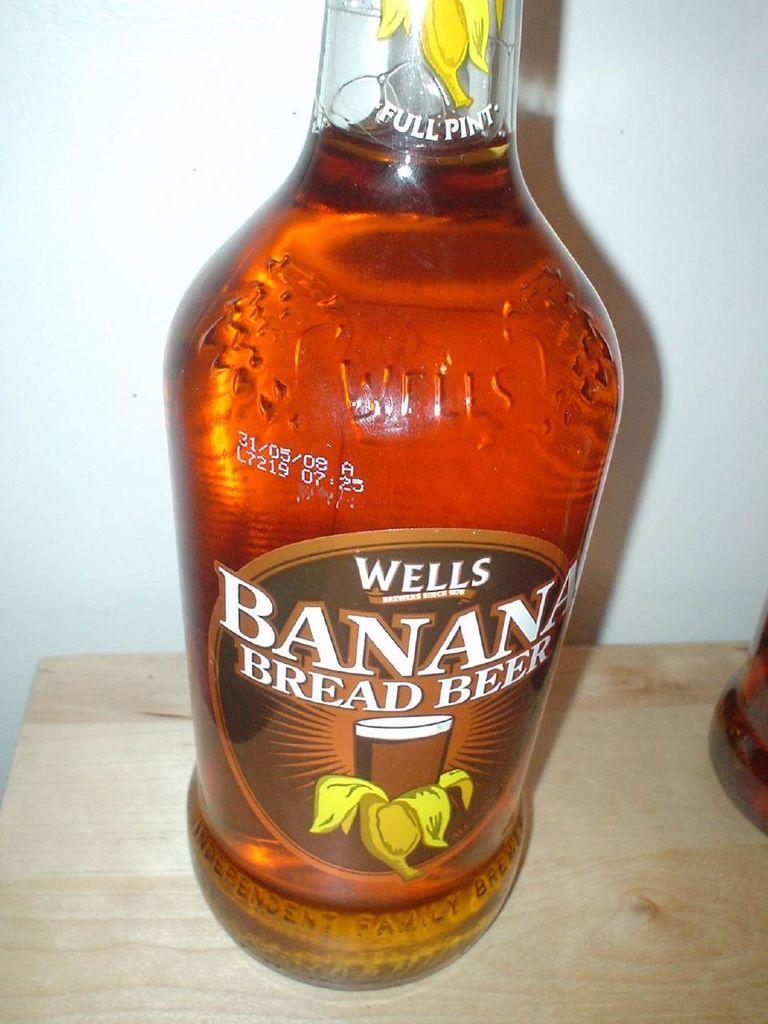<image>
Share a concise interpretation of the image provided. A bottle of Wells Banana Bread Beer sits on a shelf 